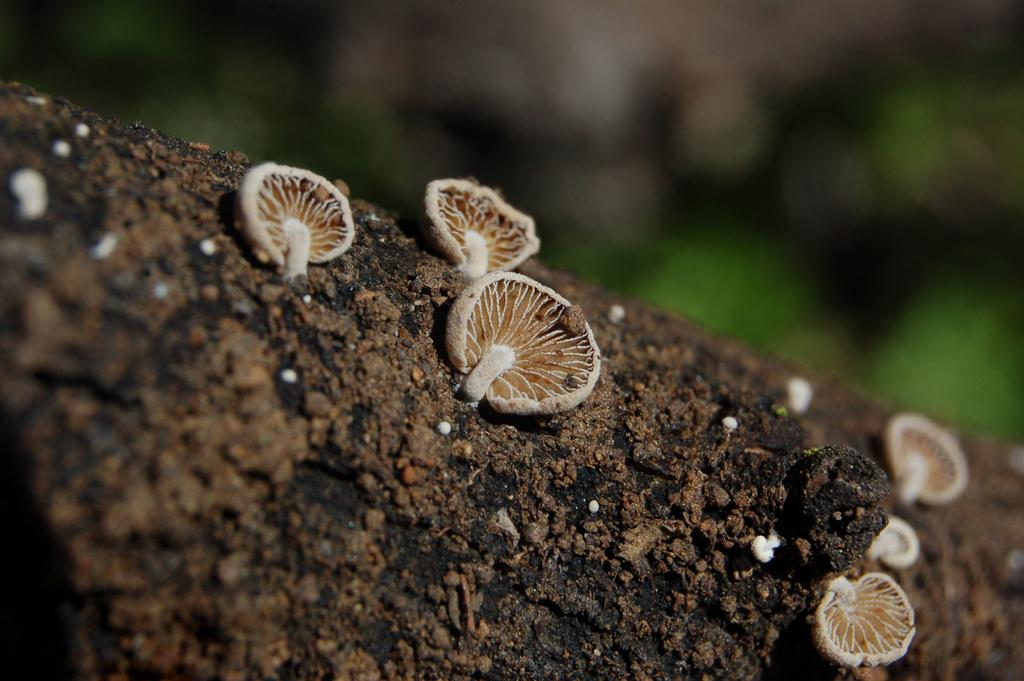What type of vegetation can be seen on the ground in the image? There are mushrooms on the ground in the image. Can you describe the background of the image? The background of the image is blurry. How many tomatoes are visible in the image? There are no tomatoes present in the image. What type of calculator can be seen in the image? There is no calculator present in the image. 